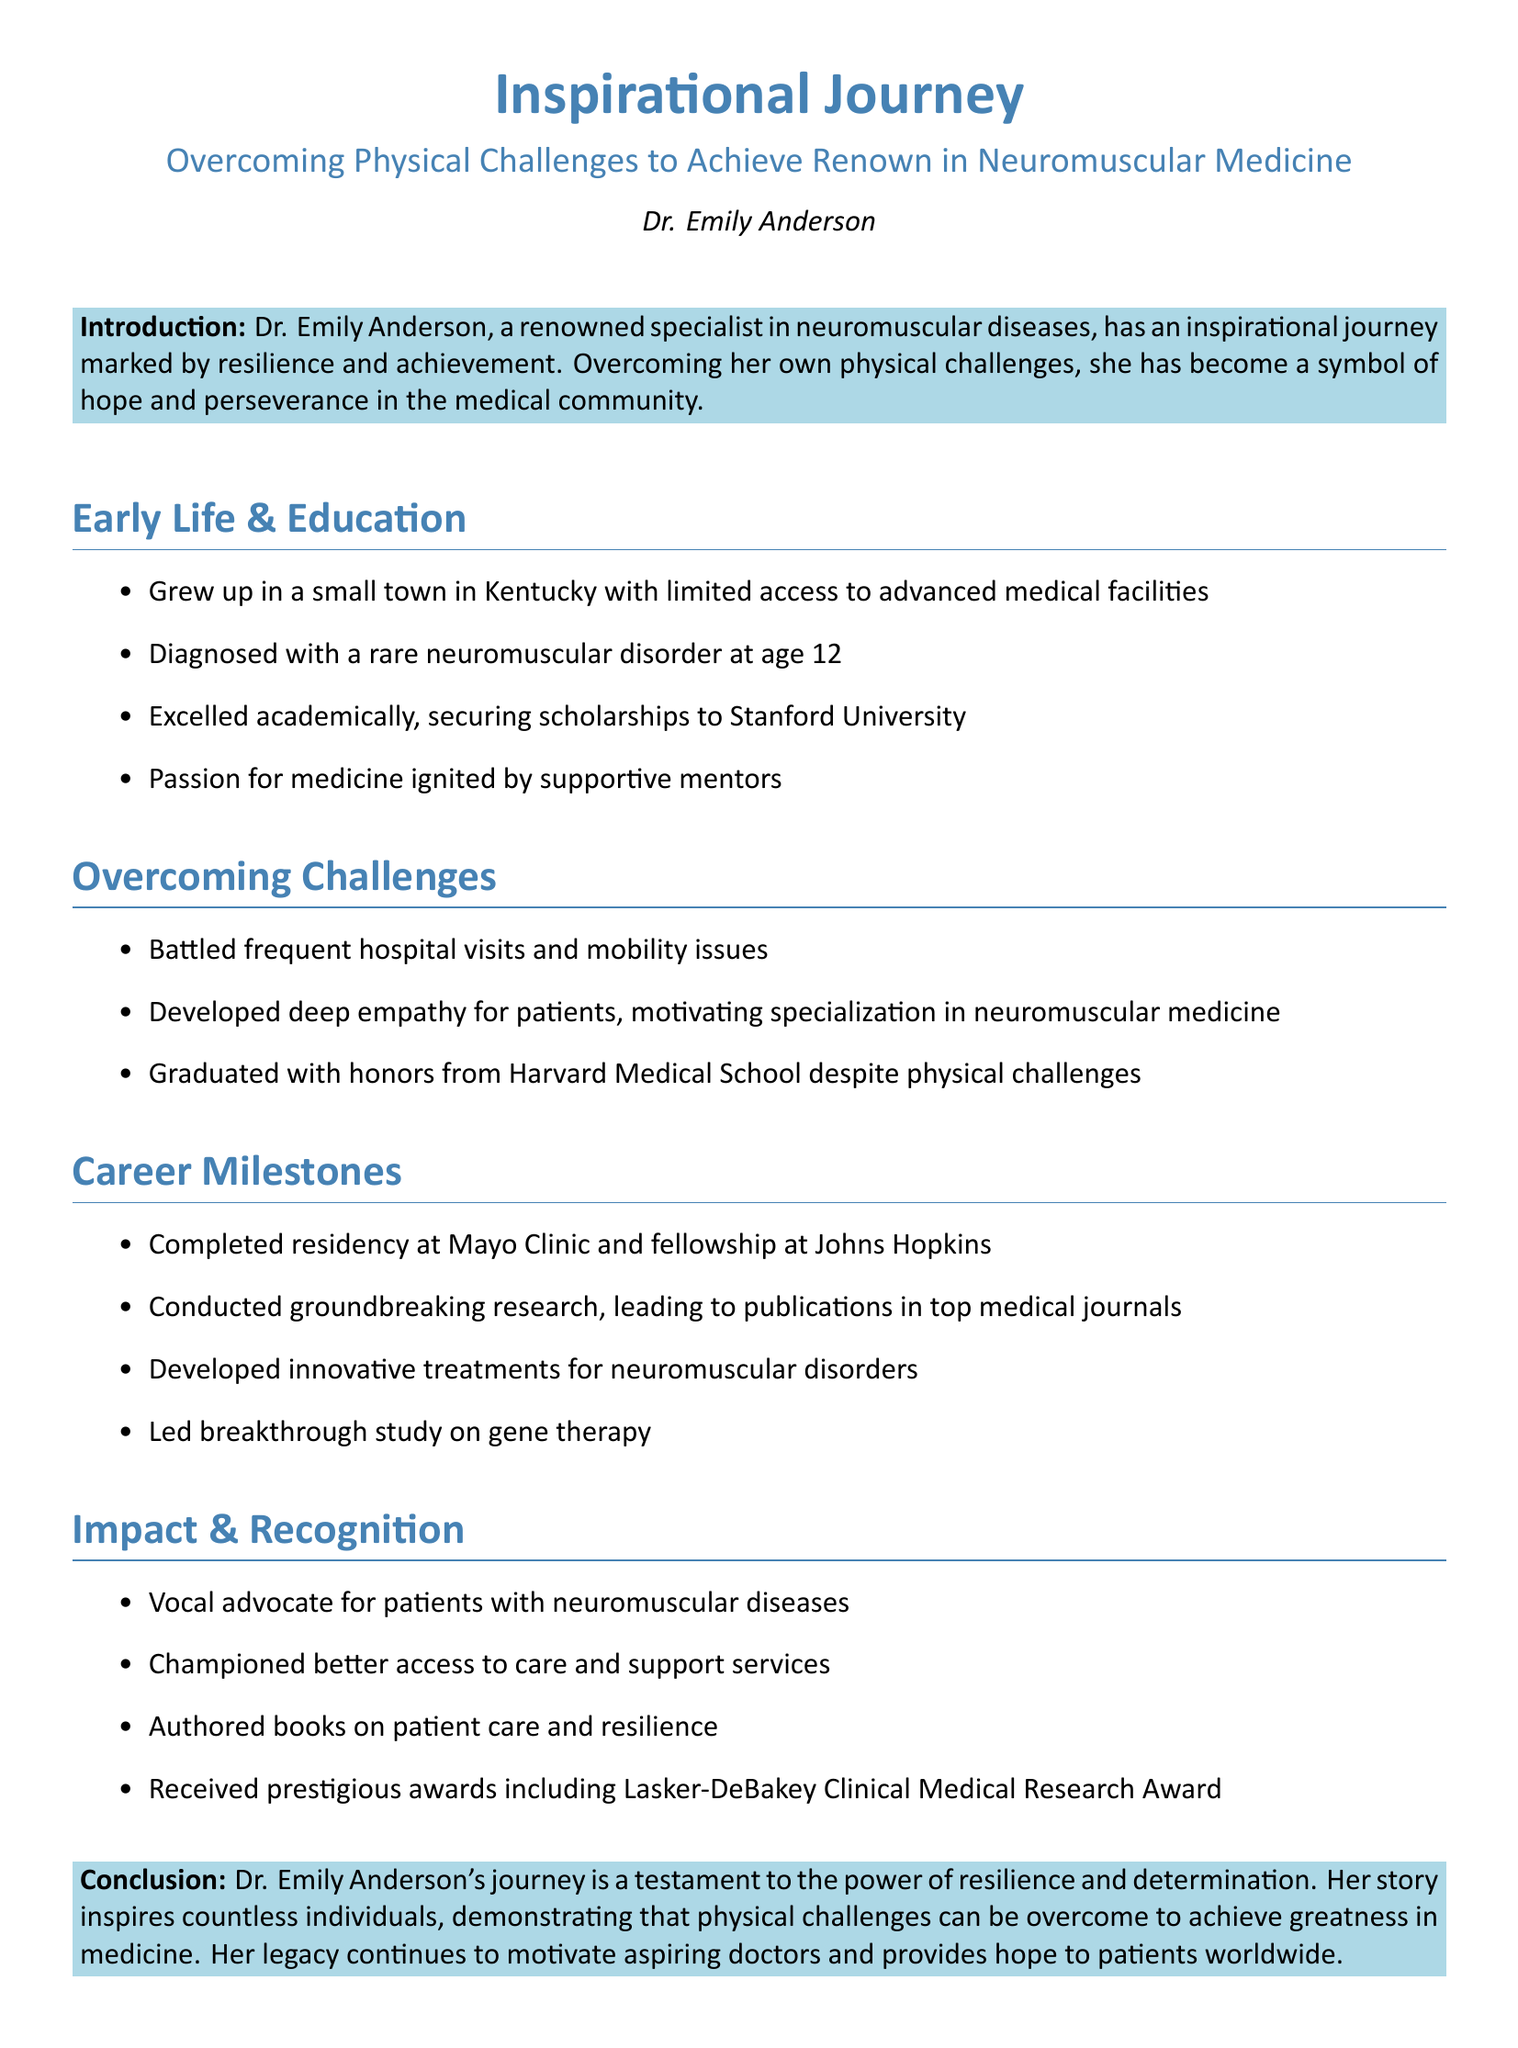what is Dr. Emily Anderson's field of specialization? Dr. Emily Anderson specializes in neuromuscular diseases
Answer: neuromuscular diseases at what age was Dr. Anderson diagnosed with a rare neuromuscular disorder? Dr. Anderson was diagnosed with the disorder at age 12.
Answer: age 12 which university did Dr. Anderson secure scholarships to attend? Dr. Anderson secured scholarships to Stanford University.
Answer: Stanford University who was a significant influence on Dr. Anderson's passion for medicine? Her passion for medicine was ignited by supportive mentors.
Answer: supportive mentors what prestigious award did Dr. Anderson receive? Dr. Anderson received the Lasker-DeBakey Clinical Medical Research Award.
Answer: Lasker-DeBakey Clinical Medical Research Award how did Dr. Anderson's personal challenges influence her career choice? Her personal challenges developed deep empathy for patients, motivating her specialization.
Answer: deep empathy for patients what types of treatments has Dr. Anderson developed? Dr. Anderson has developed innovative treatments for neuromuscular disorders.
Answer: innovative treatments for neuromuscular disorders which institutions did Dr. Anderson complete her residency and fellowship? She completed her residency at Mayo Clinic and fellowship at Johns Hopkins.
Answer: Mayo Clinic and Johns Hopkins what does the conclusion suggest about Dr. Anderson's legacy? The conclusion suggests her legacy continues to motivate aspiring doctors and provides hope.
Answer: motivate aspiring doctors and provides hope 